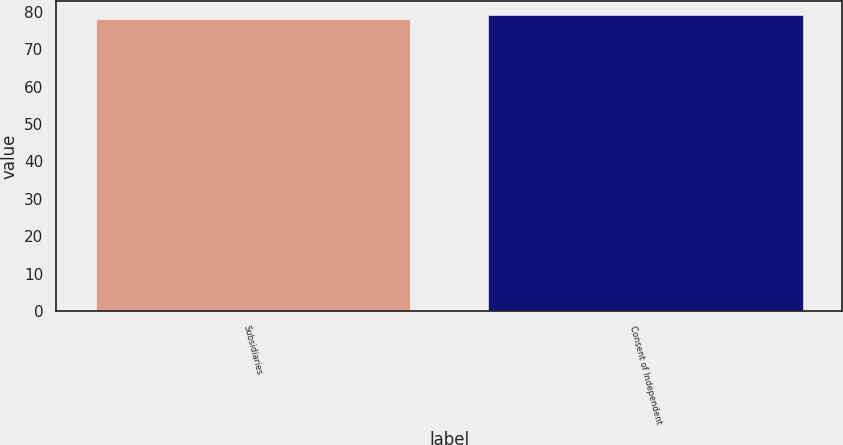Convert chart. <chart><loc_0><loc_0><loc_500><loc_500><bar_chart><fcel>Subsidiaries<fcel>Consent of Independent<nl><fcel>78<fcel>79<nl></chart> 